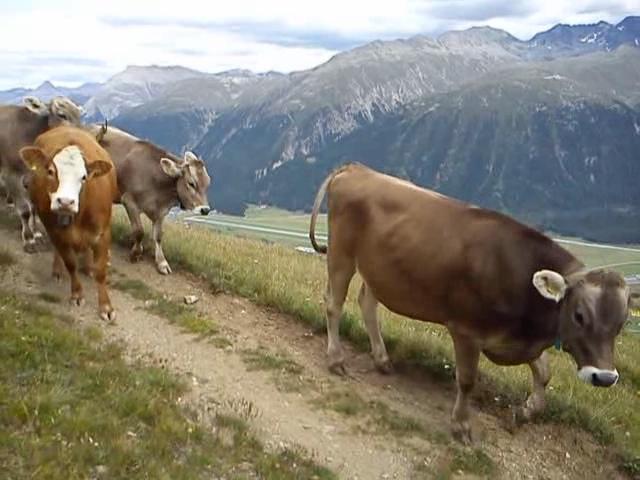How many cows can be seen?
Give a very brief answer. 4. 